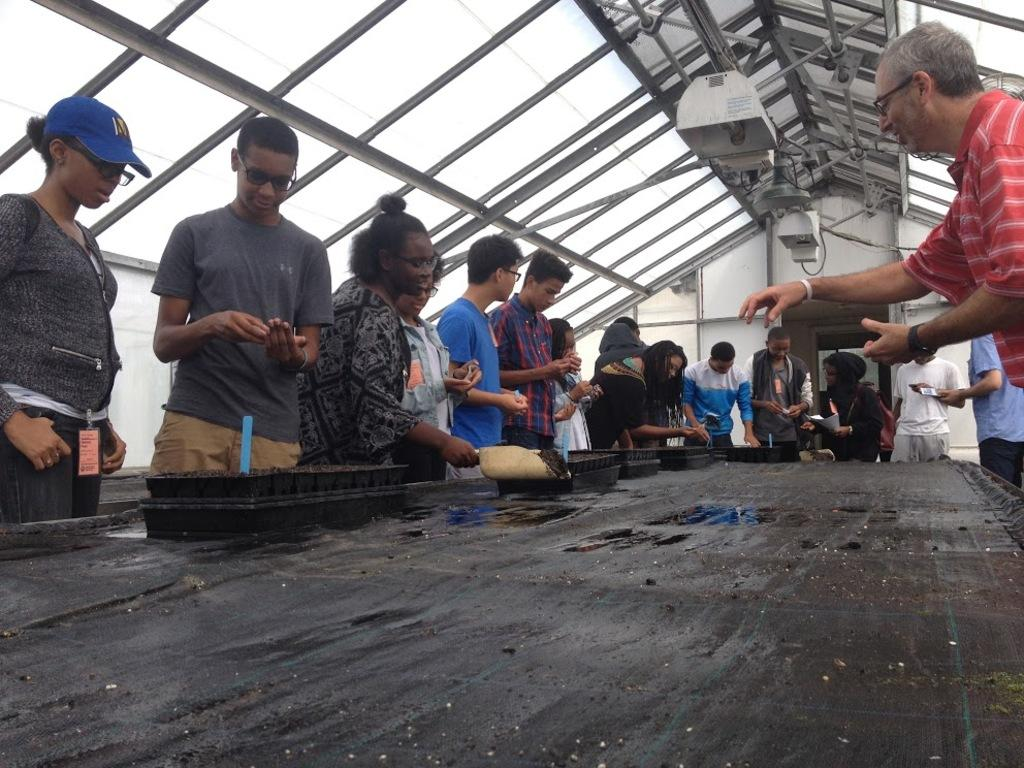What is happening in the image? There are many people standing around a table. Can you describe the attire of some people in the image? Some people are wearing glasses (specs) and some are wearing caps. What are some people doing in the image? Some people are holding objects. What can be seen on the ceiling in the image? There are rods and other items on the ceiling. What language is the manager speaking in the image? There is no manager present in the image, and therefore no language can be attributed to a manager. 